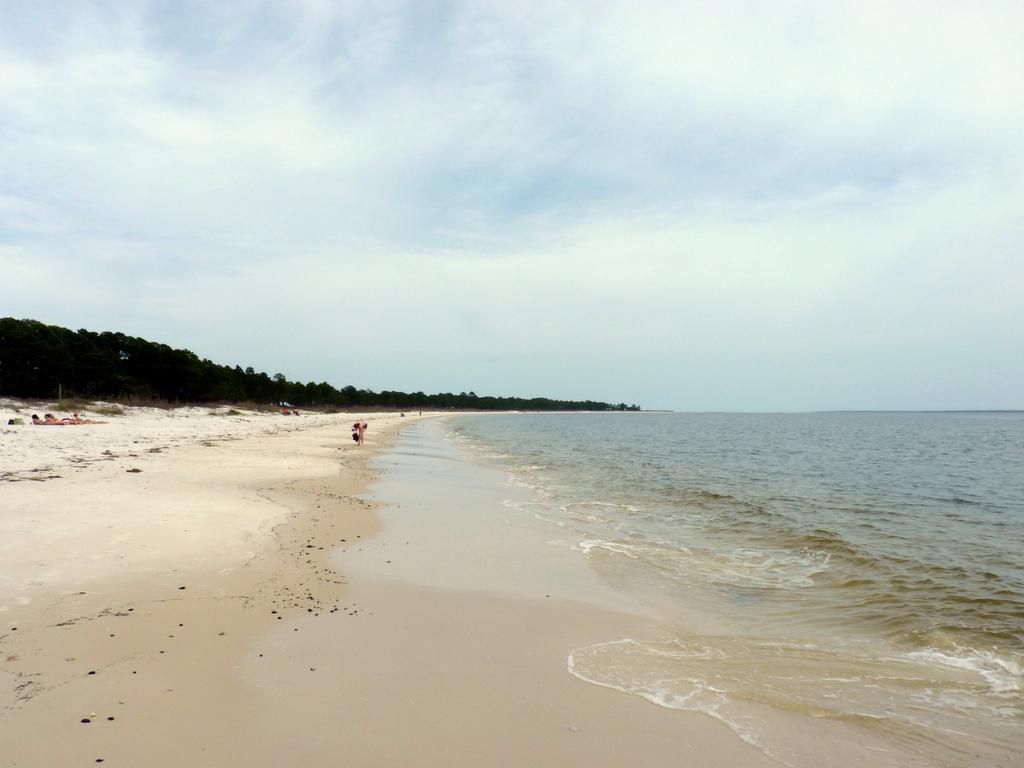Can you describe this image briefly? In this image, we can see a sea shore and water. Background we can see trees, few people and sky. 